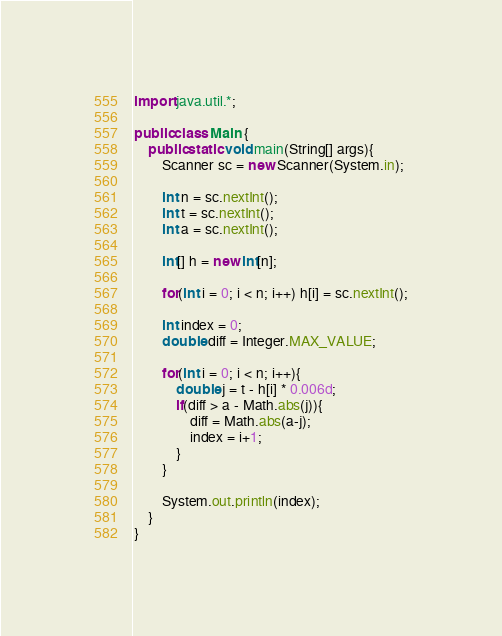Convert code to text. <code><loc_0><loc_0><loc_500><loc_500><_Java_>import java.util.*;

public class Main {
    public static void main(String[] args){
        Scanner sc = new Scanner(System.in);
        
        int n = sc.nextInt();
        int t = sc.nextInt();
        int a = sc.nextInt();
        
        int[] h = new int[n];
        
        for(int i = 0; i < n; i++) h[i] = sc.nextInt();
        
        int index = 0;
        double diff = Integer.MAX_VALUE;
        
        for(int i = 0; i < n; i++){
            double j = t - h[i] * 0.006d;
            if(diff > a - Math.abs(j)){
                diff = Math.abs(a-j);
                index = i+1;
            }
        }
        
        System.out.println(index);
    }
}
</code> 